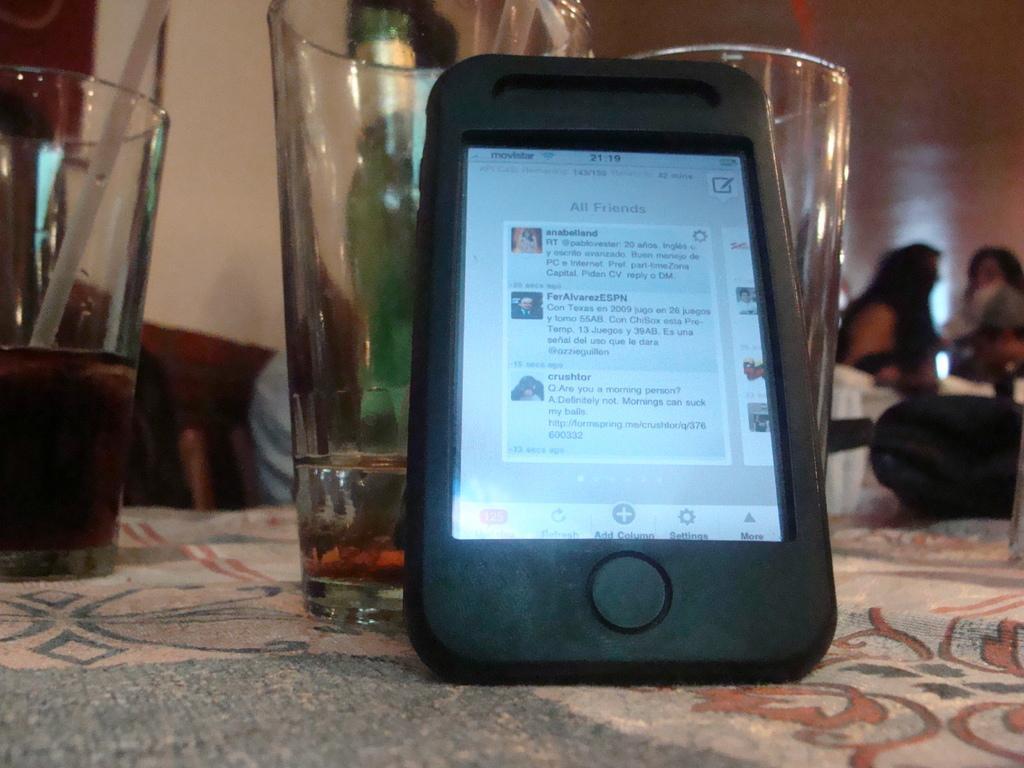Please provide a concise description of this image. In the picture we can see a table with a tablecloth on it, we can see a mobile phone and some glasses of wine and wine bottle and in the background also we can see some people are sitting on the chairs near the table. 